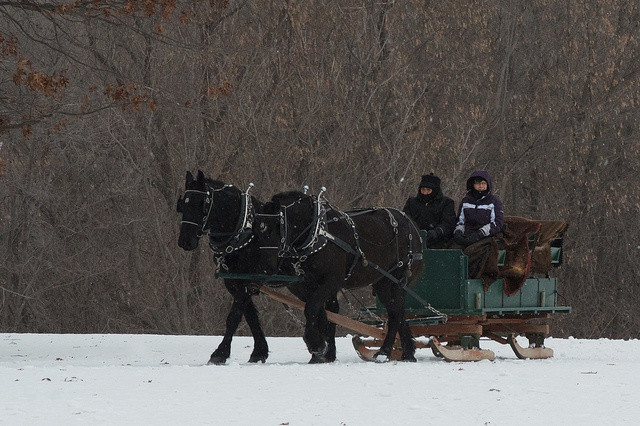Describe the objects in this image and their specific colors. I can see horse in black, gray, and darkgray tones, horse in black, gray, lightgray, and darkgray tones, people in black, gray, and darkgray tones, and people in black, gray, and maroon tones in this image. 